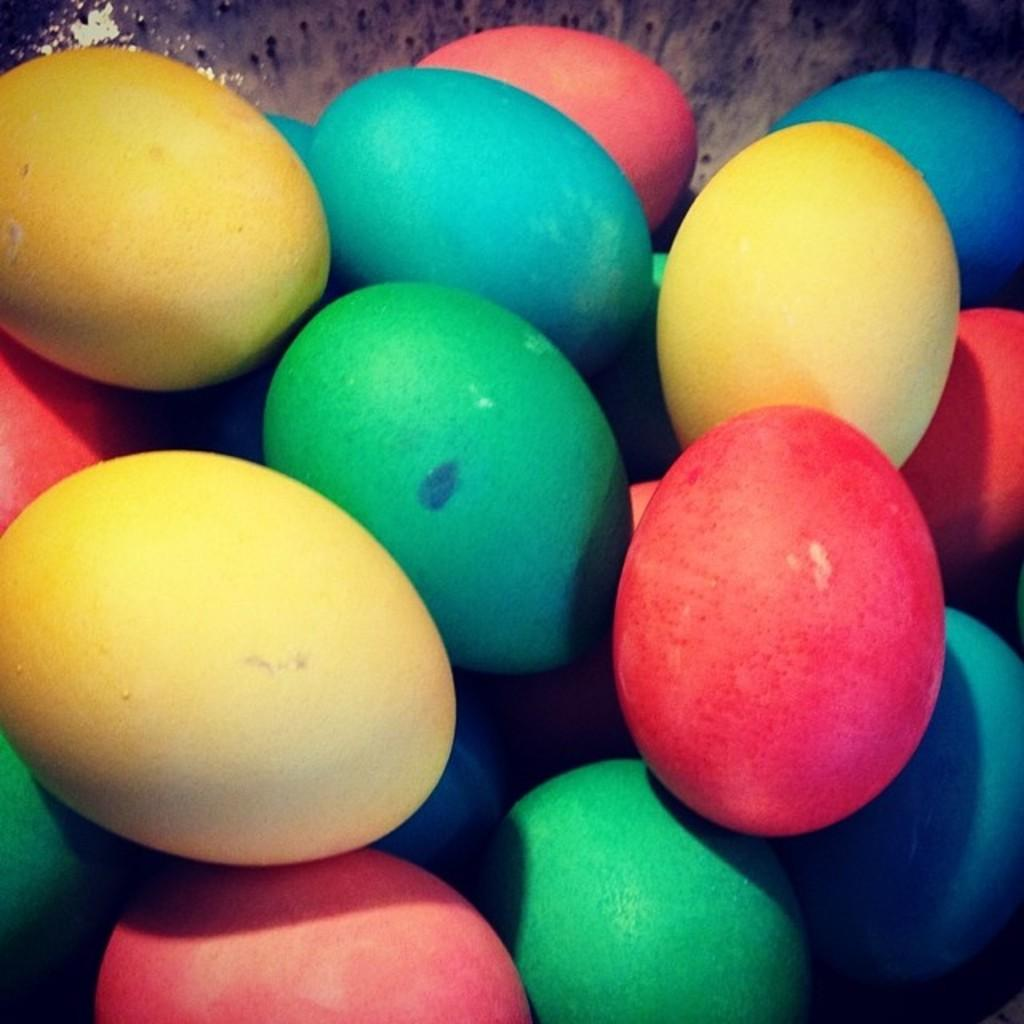What is the main subject of the image? The main subject of the image is a group of colored eggs. How are the colored eggs arranged in the image? The colored eggs are placed on a surface. What type of boats can be seen floating in the milk in the image? There are no boats or milk present in the image; it features a group of colored eggs placed on a surface. 